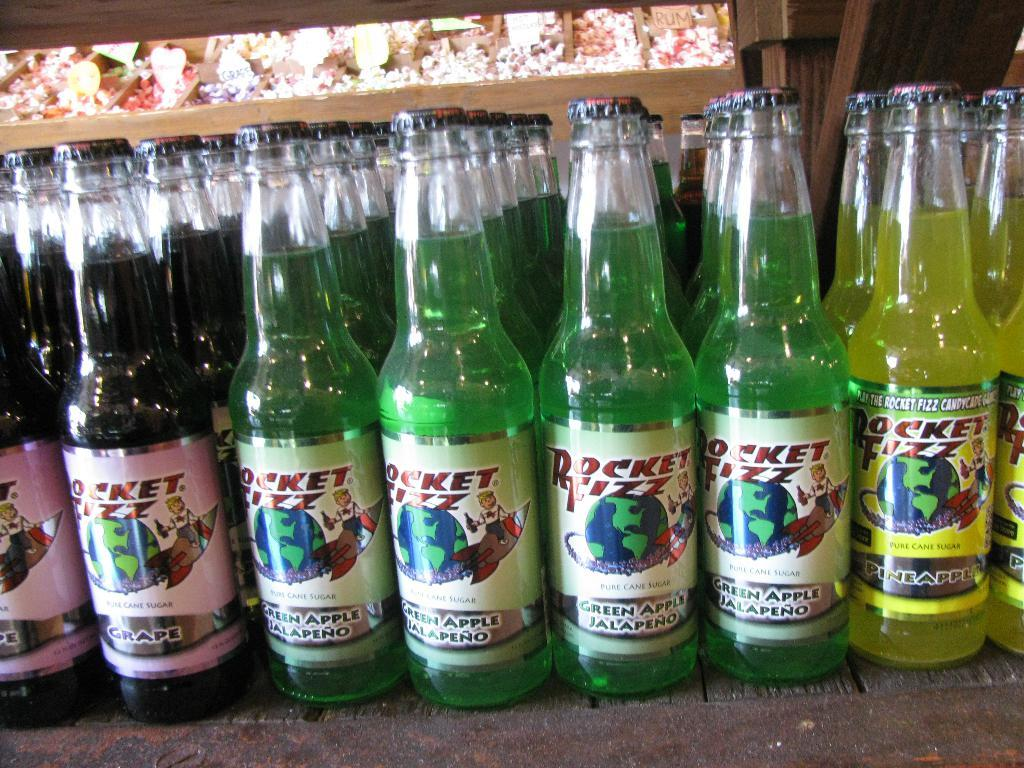Provide a one-sentence caption for the provided image. bottles standing next to one another that says 'rocket fizz' on them. 